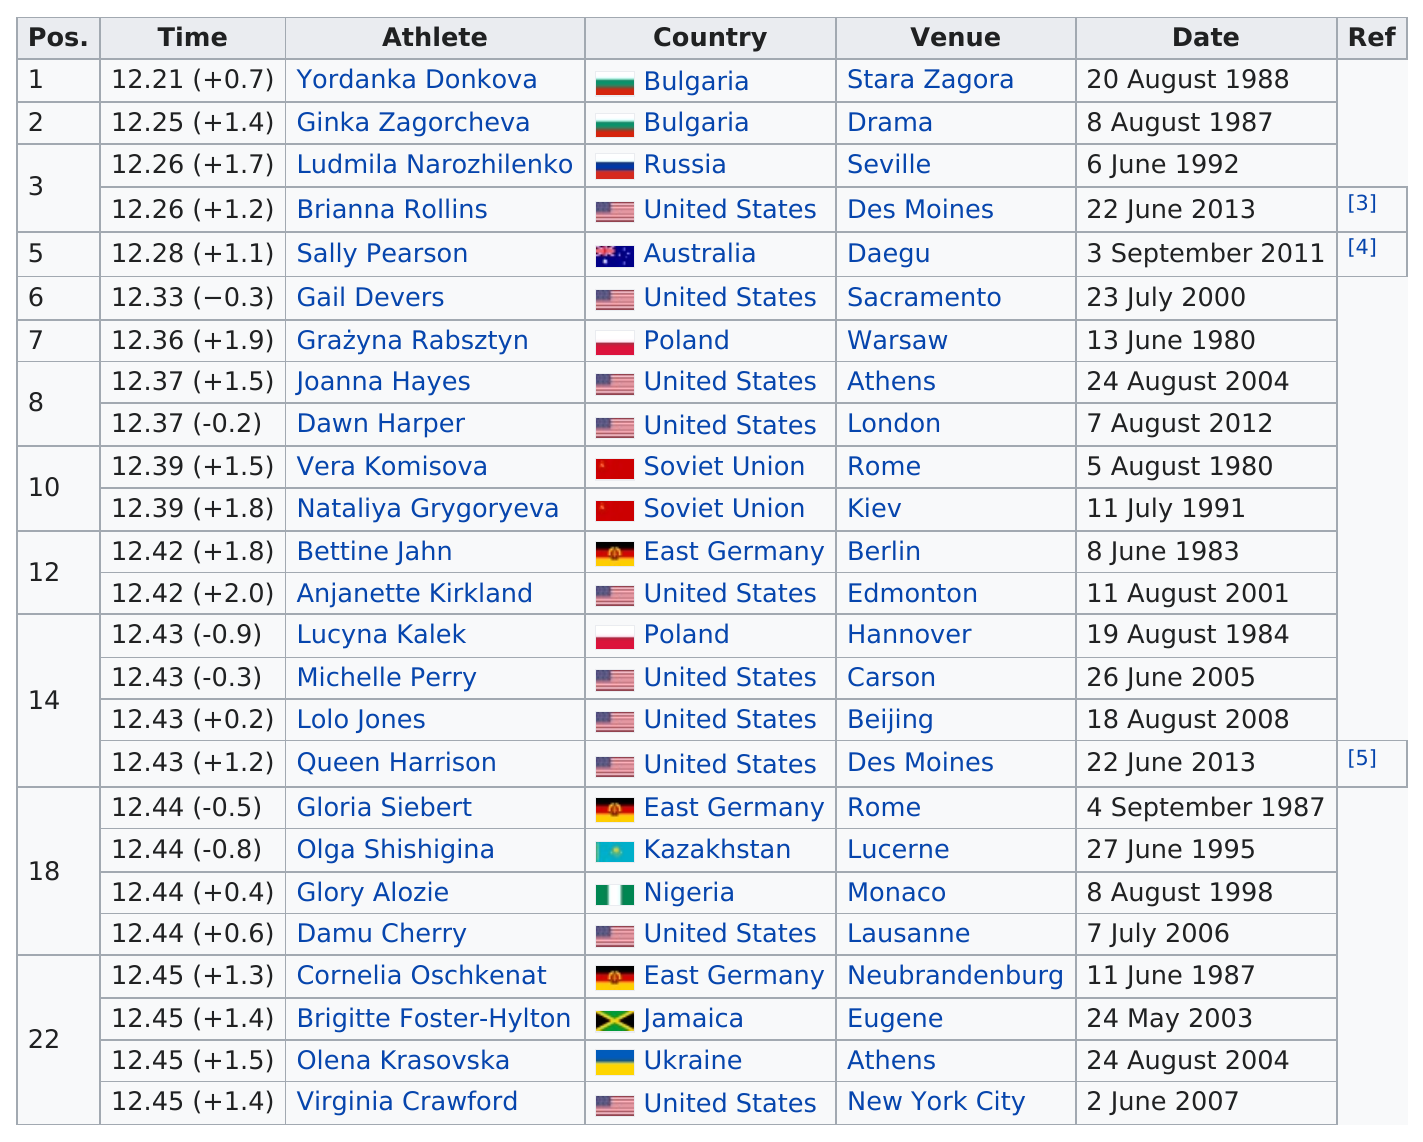Give some essential details in this illustration. A total of 2 athletes are representing Bulgaria. To make the top 25 list, an athlete's time must be no more than 12.45 minutes. Gail Devers held the position number 6. Until dawn harper finished, the process took approximately 12.37 minutes. Out of the total number of athletes, 10 of them came from the United States. 